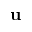<formula> <loc_0><loc_0><loc_500><loc_500>u</formula> 